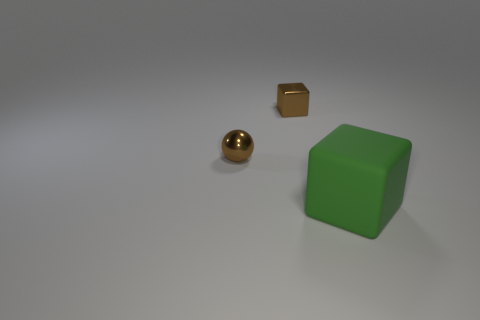Subtract all purple balls. Subtract all purple cubes. How many balls are left? 1 Add 3 large blocks. How many objects exist? 6 Subtract all blocks. How many objects are left? 1 Add 3 big matte objects. How many big matte objects exist? 4 Subtract 1 brown cubes. How many objects are left? 2 Subtract all large blue blocks. Subtract all big rubber blocks. How many objects are left? 2 Add 1 large green things. How many large green things are left? 2 